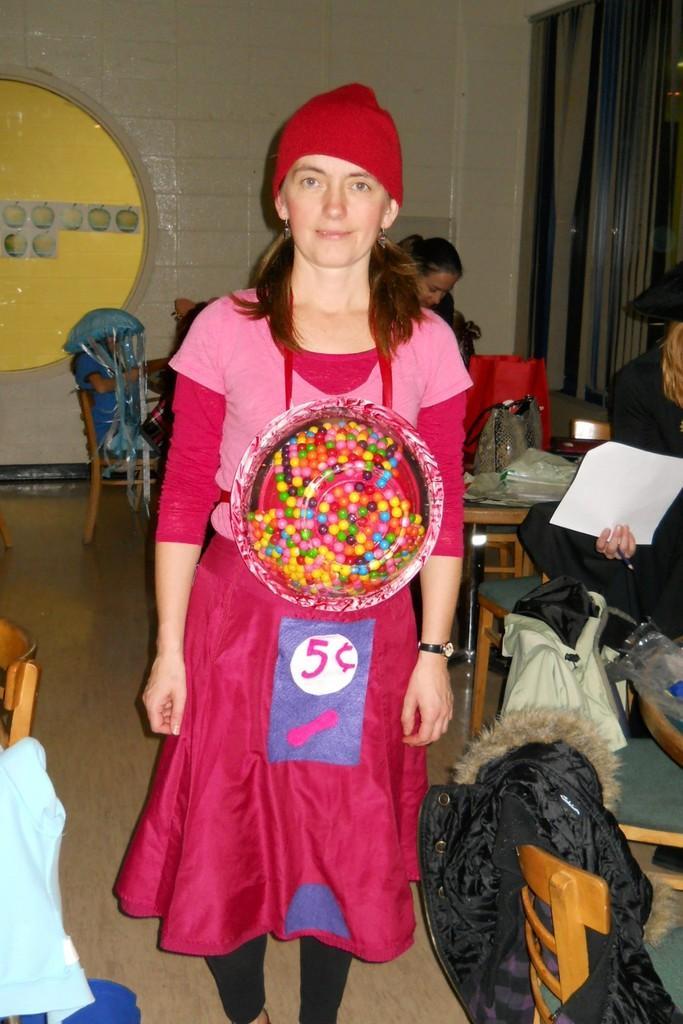Describe this image in one or two sentences. In this picture there is a women wearing red color dress with colorful cap, standing and giving pose to the camera. Behind we can see some chairs and girls, sitting and doing the work. In the background we can see the grey wall and blue color curtain. 